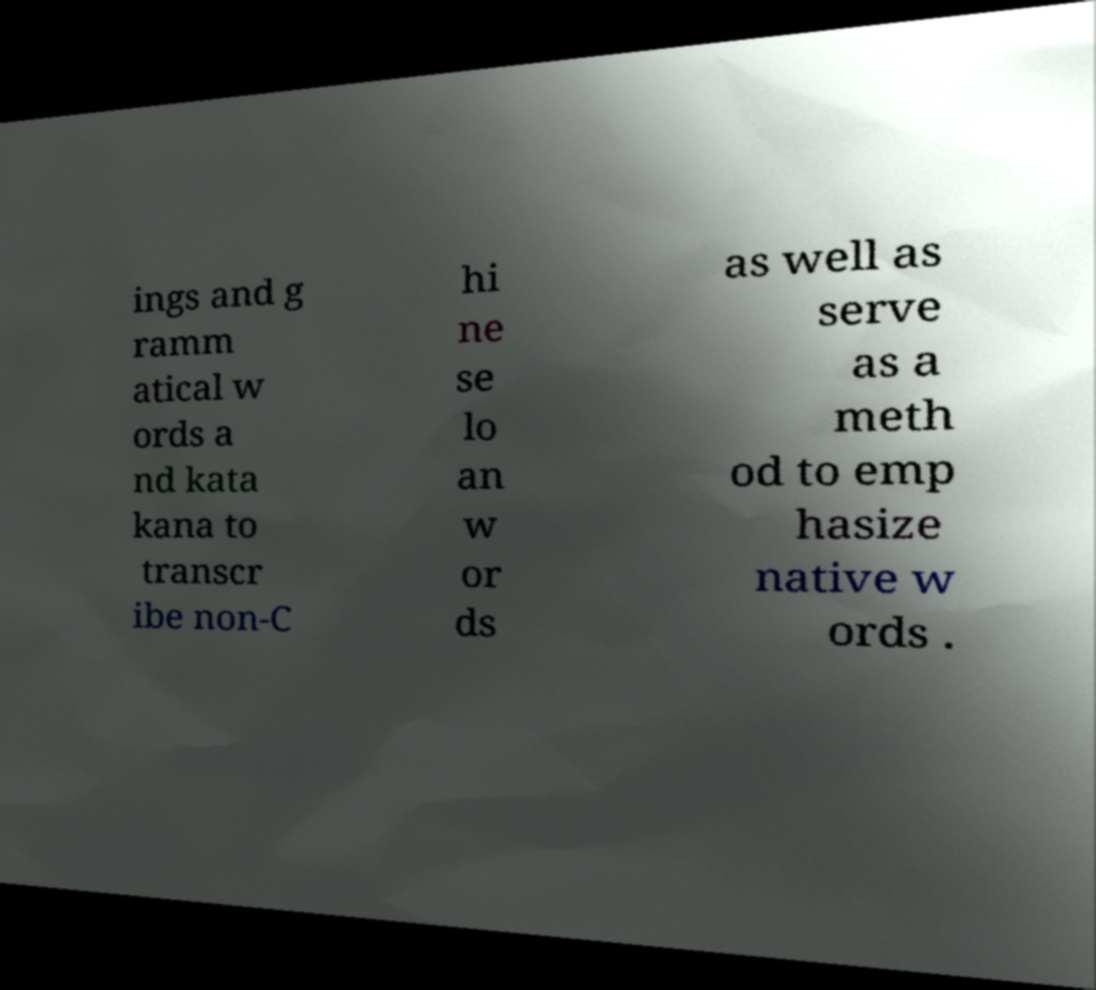What messages or text are displayed in this image? I need them in a readable, typed format. ings and g ramm atical w ords a nd kata kana to transcr ibe non-C hi ne se lo an w or ds as well as serve as a meth od to emp hasize native w ords . 